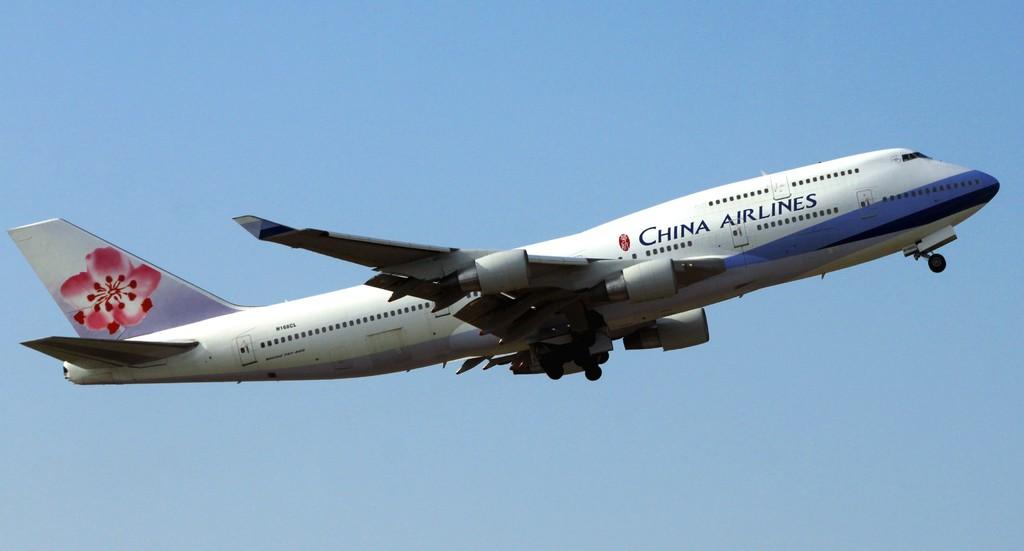What airlines is this?
Your response must be concise. China airlines. What airline is this plane from?
Provide a short and direct response. China airlines. 